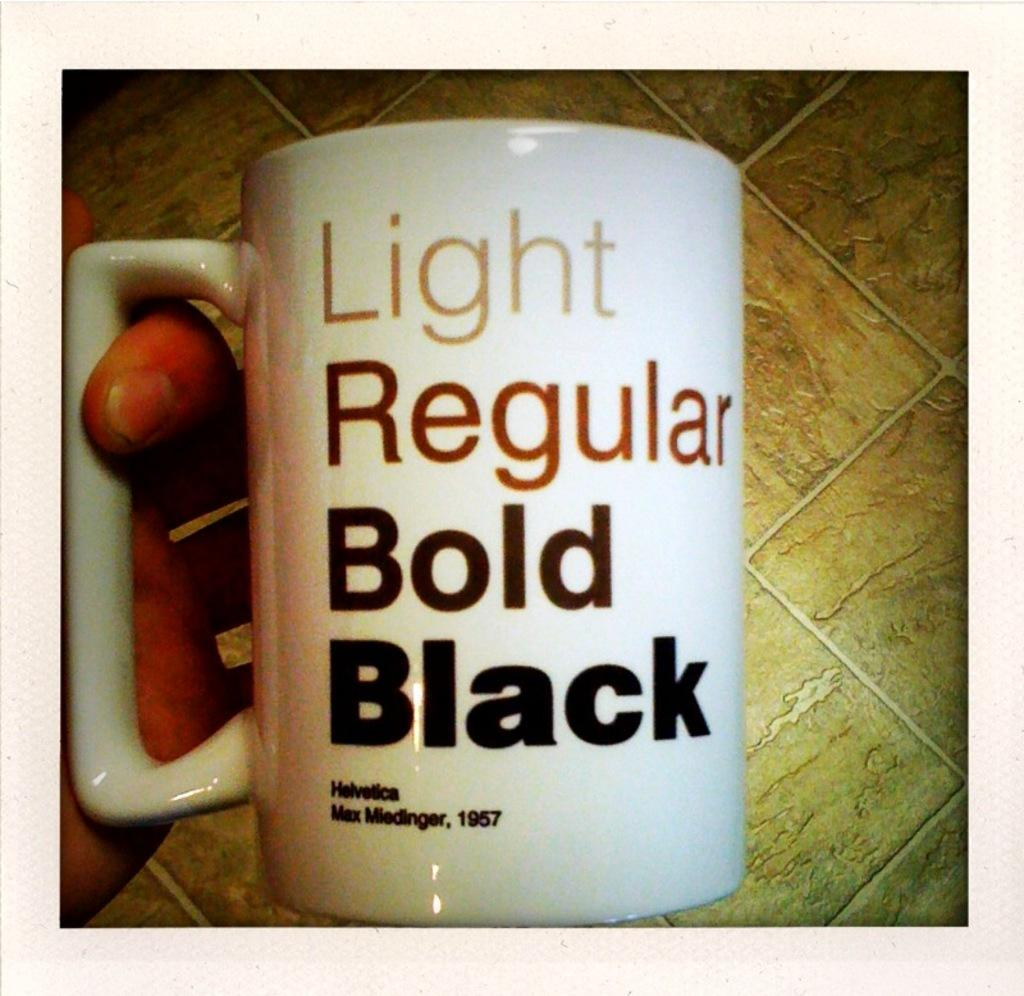Provide a one-sentence caption for the provided image. A coffee cup that reads Light, regular, bold and black. 